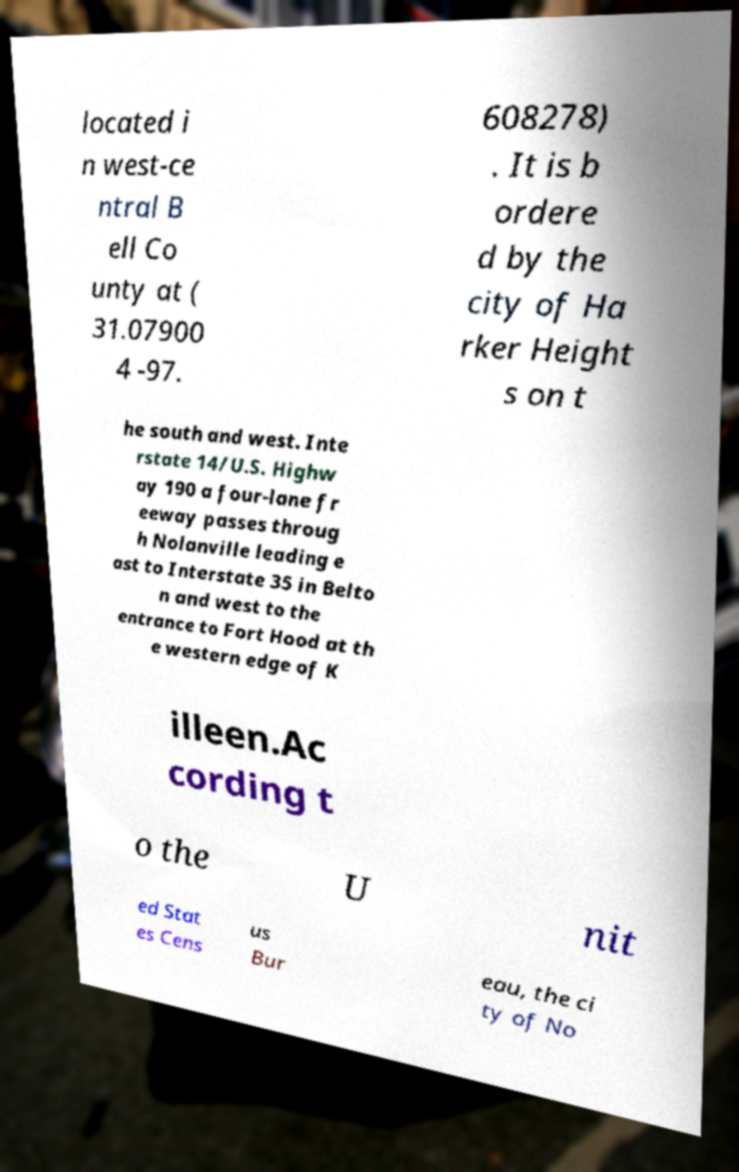Could you assist in decoding the text presented in this image and type it out clearly? located i n west-ce ntral B ell Co unty at ( 31.07900 4 -97. 608278) . It is b ordere d by the city of Ha rker Height s on t he south and west. Inte rstate 14/U.S. Highw ay 190 a four-lane fr eeway passes throug h Nolanville leading e ast to Interstate 35 in Belto n and west to the entrance to Fort Hood at th e western edge of K illeen.Ac cording t o the U nit ed Stat es Cens us Bur eau, the ci ty of No 